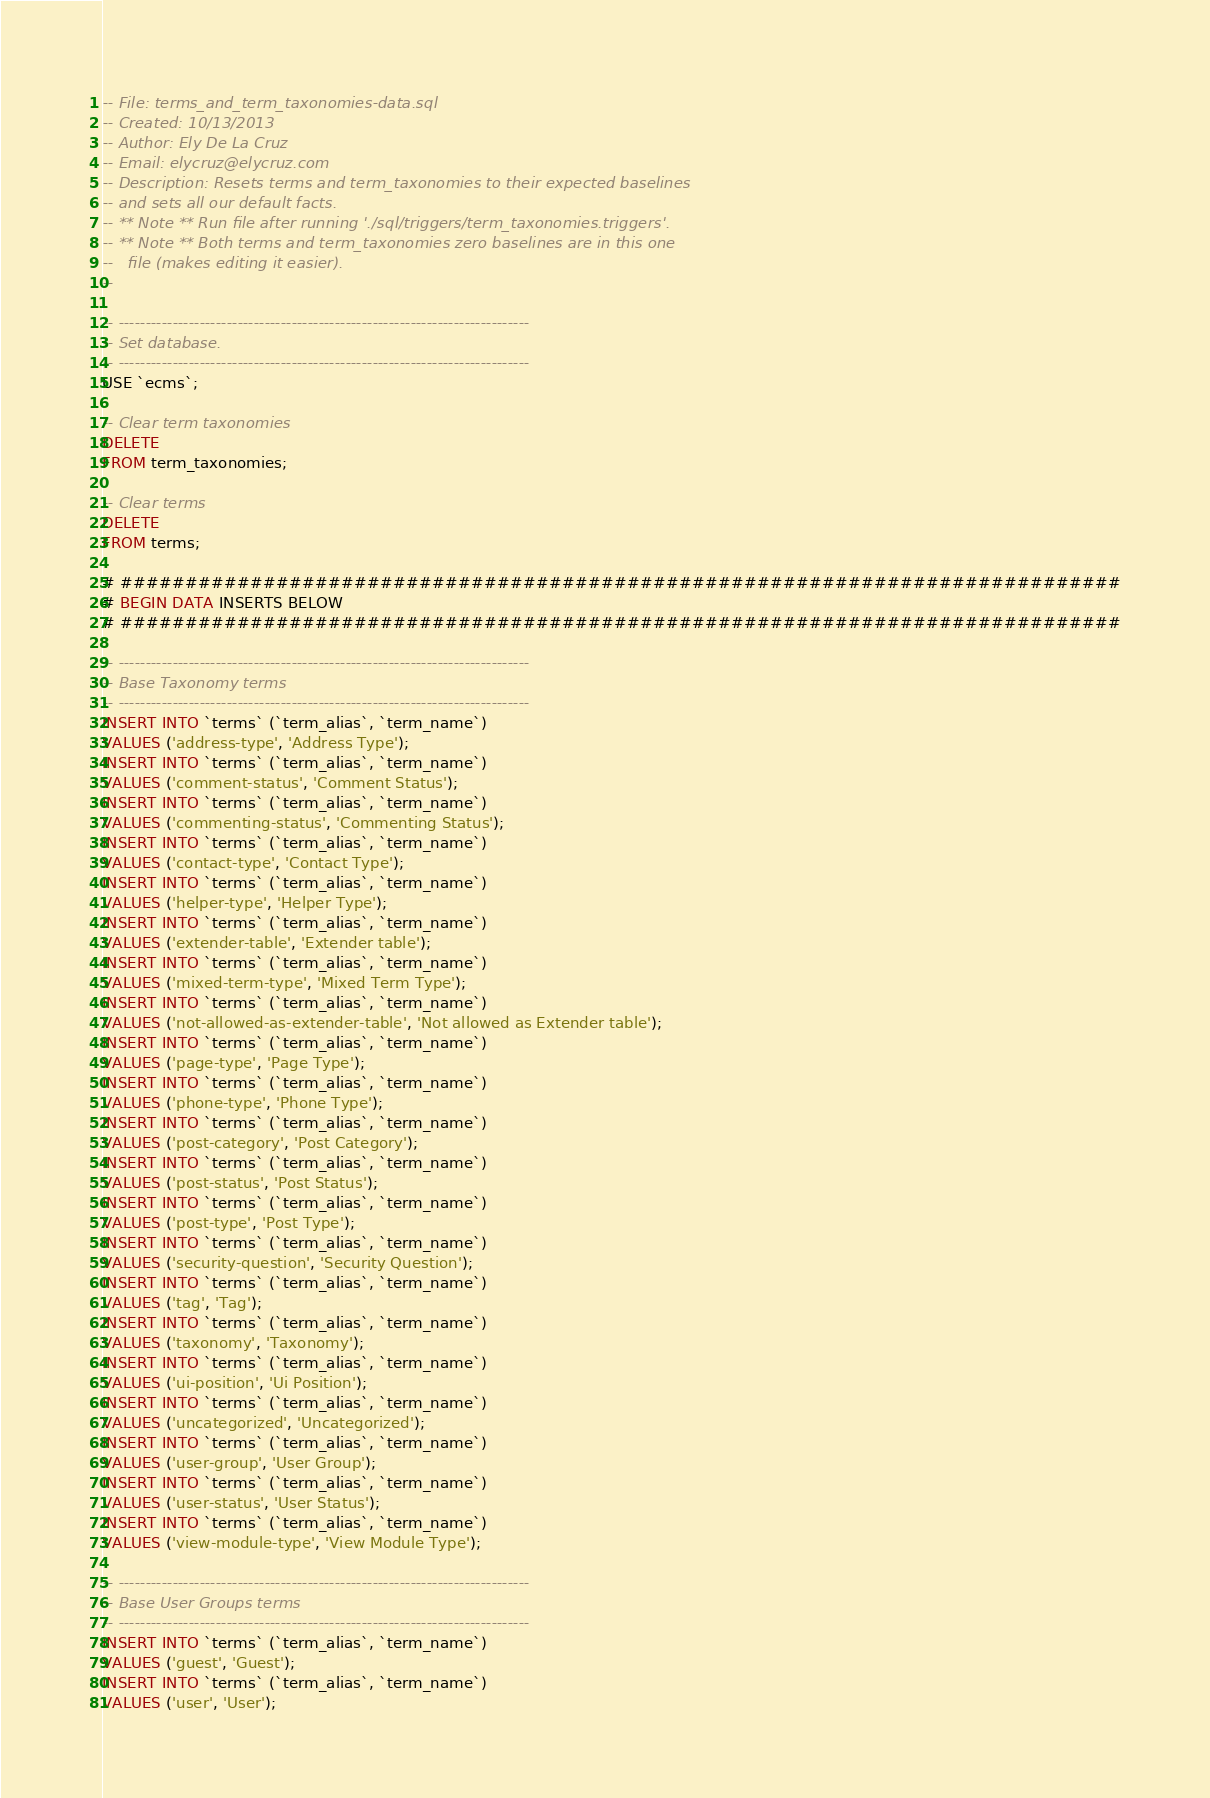Convert code to text. <code><loc_0><loc_0><loc_500><loc_500><_SQL_>-- File: terms_and_term_taxonomies-data.sql
-- Created: 10/13/2013
-- Author: Ely De La Cruz
-- Email: elycruz@elycruz.com
-- Description: Resets terms and term_taxonomies to their expected baselines
-- and sets all our default facts.
-- ** Note ** Run file after running './sql/triggers/term_taxonomies.triggers'.
-- ** Note ** Both terms and term_taxonomies zero baselines are in this one
--   file (makes editing it easier).
--

-- ----------------------------------------------------------------------------
-- Set database.
-- ----------------------------------------------------------------------------
USE `ecms`;

-- Clear term taxonomies
DELETE
FROM term_taxonomies;

-- Clear terms
DELETE
FROM terms;

# #############################################################################
# BEGIN DATA INSERTS BELOW
# #############################################################################

-- ----------------------------------------------------------------------------
-- Base Taxonomy terms
-- ----------------------------------------------------------------------------
INSERT INTO `terms` (`term_alias`, `term_name`)
VALUES ('address-type', 'Address Type');
INSERT INTO `terms` (`term_alias`, `term_name`)
VALUES ('comment-status', 'Comment Status');
INSERT INTO `terms` (`term_alias`, `term_name`)
VALUES ('commenting-status', 'Commenting Status');
INSERT INTO `terms` (`term_alias`, `term_name`)
VALUES ('contact-type', 'Contact Type');
INSERT INTO `terms` (`term_alias`, `term_name`)
VALUES ('helper-type', 'Helper Type');
INSERT INTO `terms` (`term_alias`, `term_name`)
VALUES ('extender-table', 'Extender table');
INSERT INTO `terms` (`term_alias`, `term_name`)
VALUES ('mixed-term-type', 'Mixed Term Type');
INSERT INTO `terms` (`term_alias`, `term_name`)
VALUES ('not-allowed-as-extender-table', 'Not allowed as Extender table');
INSERT INTO `terms` (`term_alias`, `term_name`)
VALUES ('page-type', 'Page Type');
INSERT INTO `terms` (`term_alias`, `term_name`)
VALUES ('phone-type', 'Phone Type');
INSERT INTO `terms` (`term_alias`, `term_name`)
VALUES ('post-category', 'Post Category');
INSERT INTO `terms` (`term_alias`, `term_name`)
VALUES ('post-status', 'Post Status');
INSERT INTO `terms` (`term_alias`, `term_name`)
VALUES ('post-type', 'Post Type');
INSERT INTO `terms` (`term_alias`, `term_name`)
VALUES ('security-question', 'Security Question');
INSERT INTO `terms` (`term_alias`, `term_name`)
VALUES ('tag', 'Tag');
INSERT INTO `terms` (`term_alias`, `term_name`)
VALUES ('taxonomy', 'Taxonomy');
INSERT INTO `terms` (`term_alias`, `term_name`)
VALUES ('ui-position', 'Ui Position');
INSERT INTO `terms` (`term_alias`, `term_name`)
VALUES ('uncategorized', 'Uncategorized');
INSERT INTO `terms` (`term_alias`, `term_name`)
VALUES ('user-group', 'User Group');
INSERT INTO `terms` (`term_alias`, `term_name`)
VALUES ('user-status', 'User Status');
INSERT INTO `terms` (`term_alias`, `term_name`)
VALUES ('view-module-type', 'View Module Type');

-- ----------------------------------------------------------------------------
-- Base User Groups terms
-- ----------------------------------------------------------------------------
INSERT INTO `terms` (`term_alias`, `term_name`)
VALUES ('guest', 'Guest');
INSERT INTO `terms` (`term_alias`, `term_name`)
VALUES ('user', 'User');</code> 